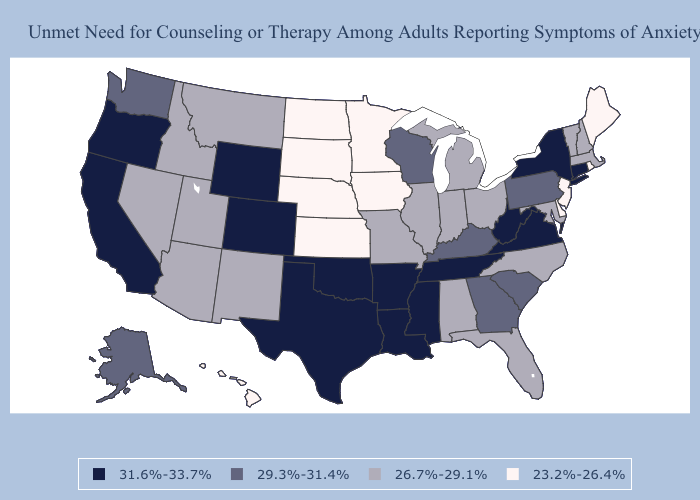Among the states that border Georgia , does Tennessee have the lowest value?
Write a very short answer. No. What is the highest value in the MidWest ?
Be succinct. 29.3%-31.4%. Does Indiana have the highest value in the MidWest?
Write a very short answer. No. Name the states that have a value in the range 31.6%-33.7%?
Short answer required. Arkansas, California, Colorado, Connecticut, Louisiana, Mississippi, New York, Oklahoma, Oregon, Tennessee, Texas, Virginia, West Virginia, Wyoming. What is the value of West Virginia?
Keep it brief. 31.6%-33.7%. Among the states that border New Hampshire , which have the lowest value?
Write a very short answer. Maine. What is the value of Idaho?
Be succinct. 26.7%-29.1%. What is the highest value in the Northeast ?
Keep it brief. 31.6%-33.7%. What is the value of Minnesota?
Concise answer only. 23.2%-26.4%. Does Florida have a lower value than Maine?
Be succinct. No. Name the states that have a value in the range 26.7%-29.1%?
Give a very brief answer. Alabama, Arizona, Florida, Idaho, Illinois, Indiana, Maryland, Massachusetts, Michigan, Missouri, Montana, Nevada, New Hampshire, New Mexico, North Carolina, Ohio, Utah, Vermont. Among the states that border Idaho , does Oregon have the highest value?
Answer briefly. Yes. What is the value of Minnesota?
Be succinct. 23.2%-26.4%. How many symbols are there in the legend?
Give a very brief answer. 4. 